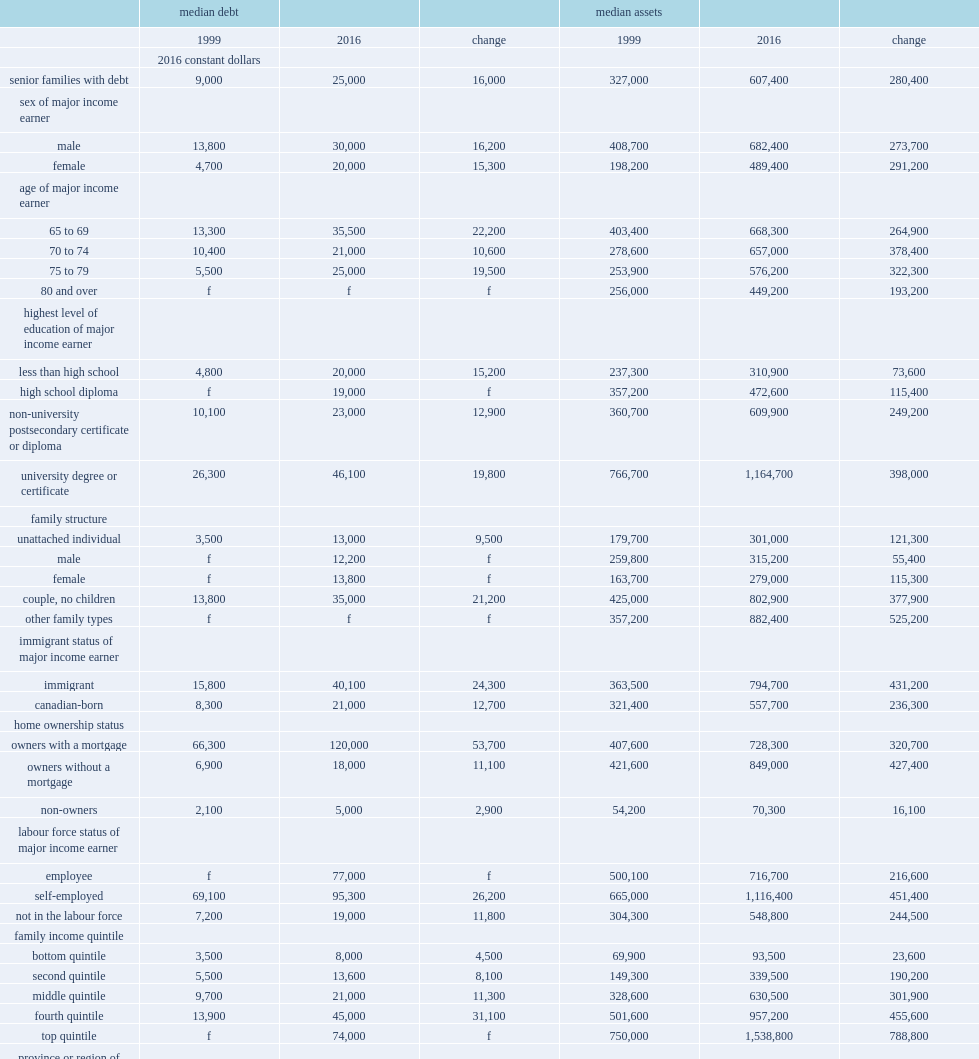What was the number of the median amount of debt held by senior families with debt (dollars)? 25000.0. What was the number of median level of assets held by senior families with debt in 2016? 607400.0. 